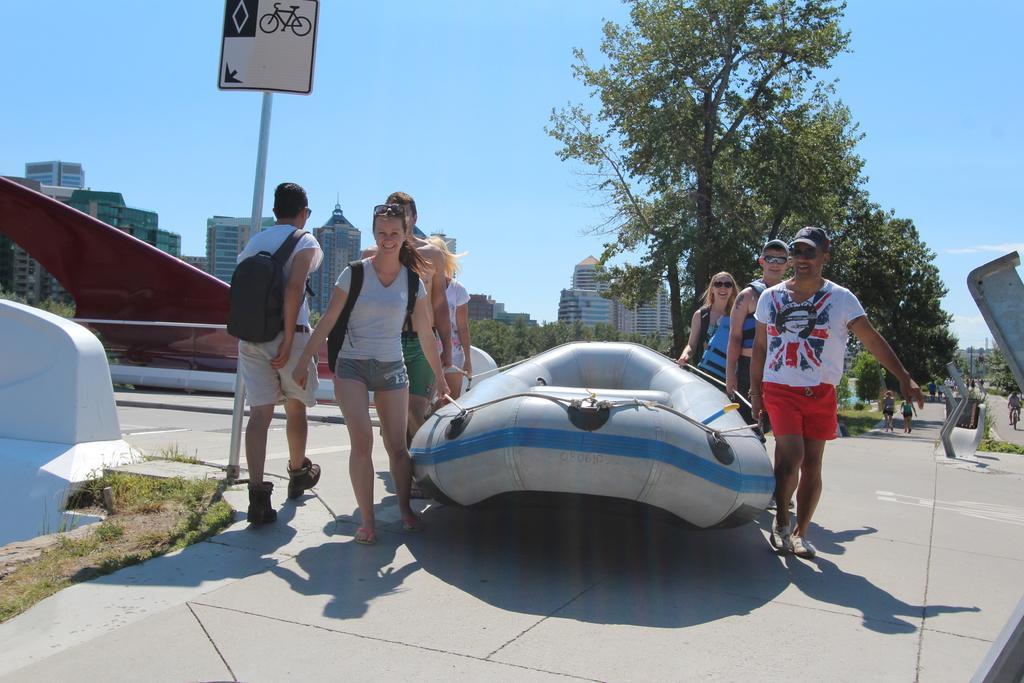How would you summarize this image in a sentence or two? In this image, we can see few people. Here a person is wearing a bag and walking. Few are carrying tube boat and smiling. Here we can see pole, sign board, trees, buildings, grass, road. Background there is a sky. 